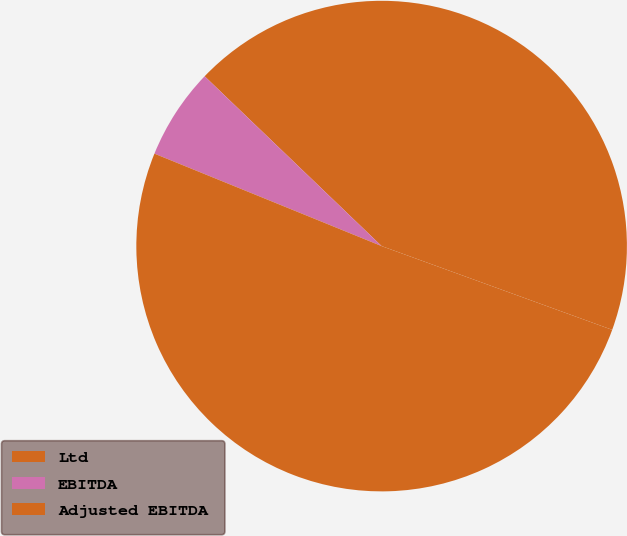Convert chart. <chart><loc_0><loc_0><loc_500><loc_500><pie_chart><fcel>Ltd<fcel>EBITDA<fcel>Adjusted EBITDA<nl><fcel>43.37%<fcel>6.02%<fcel>50.6%<nl></chart> 